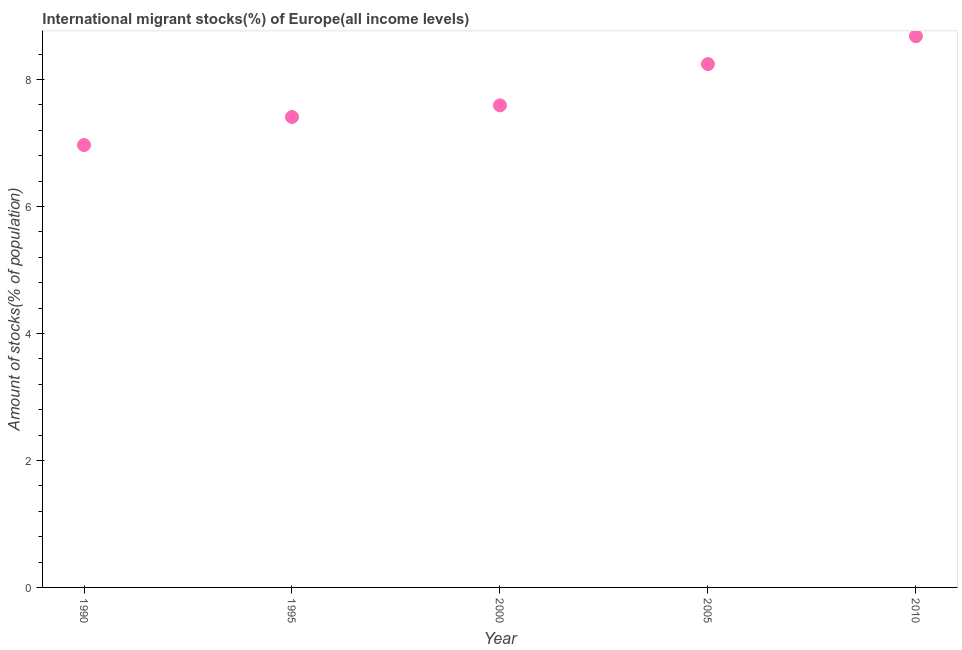What is the number of international migrant stocks in 1995?
Give a very brief answer. 7.41. Across all years, what is the maximum number of international migrant stocks?
Ensure brevity in your answer.  8.68. Across all years, what is the minimum number of international migrant stocks?
Keep it short and to the point. 6.97. In which year was the number of international migrant stocks maximum?
Your response must be concise. 2010. What is the sum of the number of international migrant stocks?
Ensure brevity in your answer.  38.9. What is the difference between the number of international migrant stocks in 1990 and 2005?
Give a very brief answer. -1.28. What is the average number of international migrant stocks per year?
Ensure brevity in your answer.  7.78. What is the median number of international migrant stocks?
Give a very brief answer. 7.59. In how many years, is the number of international migrant stocks greater than 1.2000000000000002 %?
Offer a terse response. 5. What is the ratio of the number of international migrant stocks in 1990 to that in 2000?
Offer a very short reply. 0.92. What is the difference between the highest and the second highest number of international migrant stocks?
Offer a very short reply. 0.44. Is the sum of the number of international migrant stocks in 1990 and 1995 greater than the maximum number of international migrant stocks across all years?
Ensure brevity in your answer.  Yes. What is the difference between the highest and the lowest number of international migrant stocks?
Your response must be concise. 1.71. In how many years, is the number of international migrant stocks greater than the average number of international migrant stocks taken over all years?
Offer a very short reply. 2. How many years are there in the graph?
Provide a succinct answer. 5. What is the difference between two consecutive major ticks on the Y-axis?
Offer a very short reply. 2. Are the values on the major ticks of Y-axis written in scientific E-notation?
Your response must be concise. No. What is the title of the graph?
Ensure brevity in your answer.  International migrant stocks(%) of Europe(all income levels). What is the label or title of the Y-axis?
Provide a succinct answer. Amount of stocks(% of population). What is the Amount of stocks(% of population) in 1990?
Provide a succinct answer. 6.97. What is the Amount of stocks(% of population) in 1995?
Provide a short and direct response. 7.41. What is the Amount of stocks(% of population) in 2000?
Ensure brevity in your answer.  7.59. What is the Amount of stocks(% of population) in 2005?
Give a very brief answer. 8.24. What is the Amount of stocks(% of population) in 2010?
Make the answer very short. 8.68. What is the difference between the Amount of stocks(% of population) in 1990 and 1995?
Your answer should be compact. -0.44. What is the difference between the Amount of stocks(% of population) in 1990 and 2000?
Provide a short and direct response. -0.62. What is the difference between the Amount of stocks(% of population) in 1990 and 2005?
Provide a succinct answer. -1.28. What is the difference between the Amount of stocks(% of population) in 1990 and 2010?
Provide a succinct answer. -1.71. What is the difference between the Amount of stocks(% of population) in 1995 and 2000?
Keep it short and to the point. -0.18. What is the difference between the Amount of stocks(% of population) in 1995 and 2005?
Offer a terse response. -0.83. What is the difference between the Amount of stocks(% of population) in 1995 and 2010?
Offer a very short reply. -1.27. What is the difference between the Amount of stocks(% of population) in 2000 and 2005?
Your response must be concise. -0.65. What is the difference between the Amount of stocks(% of population) in 2000 and 2010?
Your response must be concise. -1.09. What is the difference between the Amount of stocks(% of population) in 2005 and 2010?
Provide a succinct answer. -0.44. What is the ratio of the Amount of stocks(% of population) in 1990 to that in 1995?
Your response must be concise. 0.94. What is the ratio of the Amount of stocks(% of population) in 1990 to that in 2000?
Your answer should be very brief. 0.92. What is the ratio of the Amount of stocks(% of population) in 1990 to that in 2005?
Provide a succinct answer. 0.84. What is the ratio of the Amount of stocks(% of population) in 1990 to that in 2010?
Your response must be concise. 0.8. What is the ratio of the Amount of stocks(% of population) in 1995 to that in 2000?
Make the answer very short. 0.98. What is the ratio of the Amount of stocks(% of population) in 1995 to that in 2005?
Give a very brief answer. 0.9. What is the ratio of the Amount of stocks(% of population) in 1995 to that in 2010?
Your answer should be compact. 0.85. What is the ratio of the Amount of stocks(% of population) in 2000 to that in 2005?
Provide a short and direct response. 0.92. What is the ratio of the Amount of stocks(% of population) in 2000 to that in 2010?
Provide a short and direct response. 0.88. 